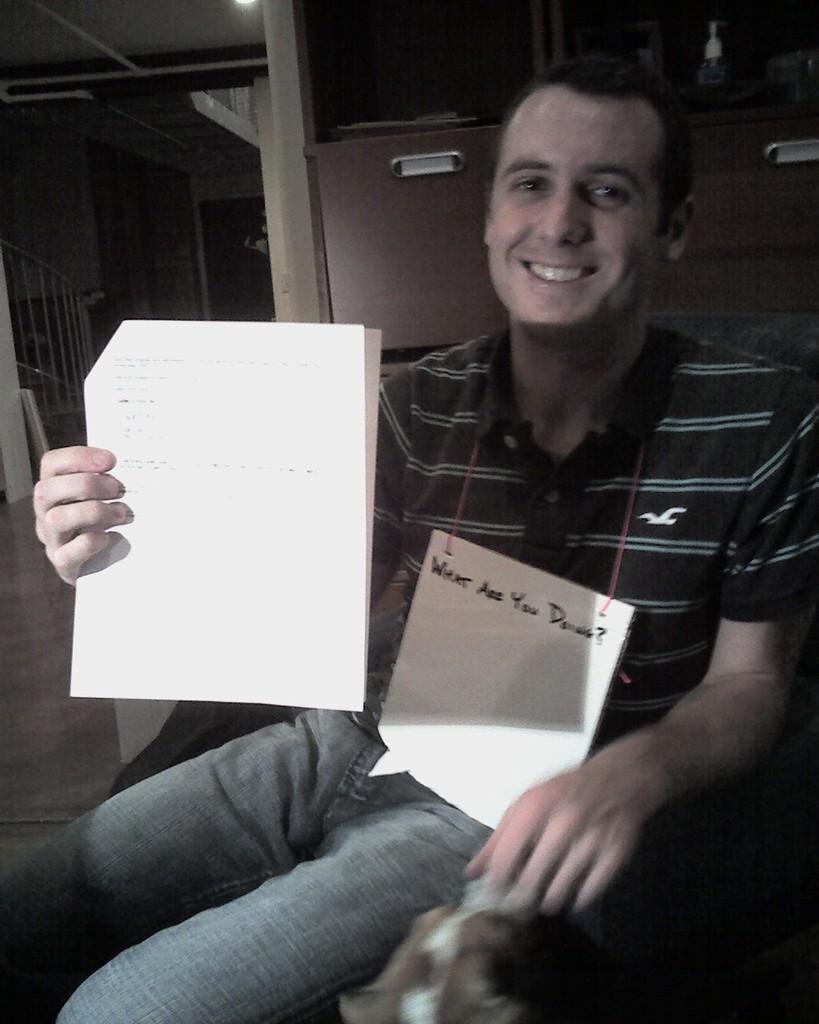Please provide a concise description of this image. In the image there is a person, he is smiling and holding some papers in his hand. Behind the person there are two cabinets and in the background there are stairs on the left. 